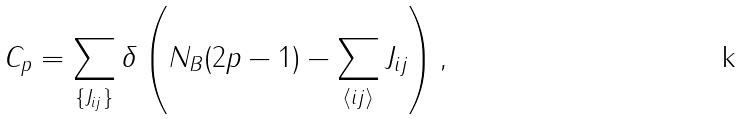Convert formula to latex. <formula><loc_0><loc_0><loc_500><loc_500>C _ { p } = \sum _ { \{ J _ { i j } \} } \delta \left ( N _ { B } ( 2 p - 1 ) - \sum _ { \langle i j \rangle } J _ { i j } \right ) ,</formula> 